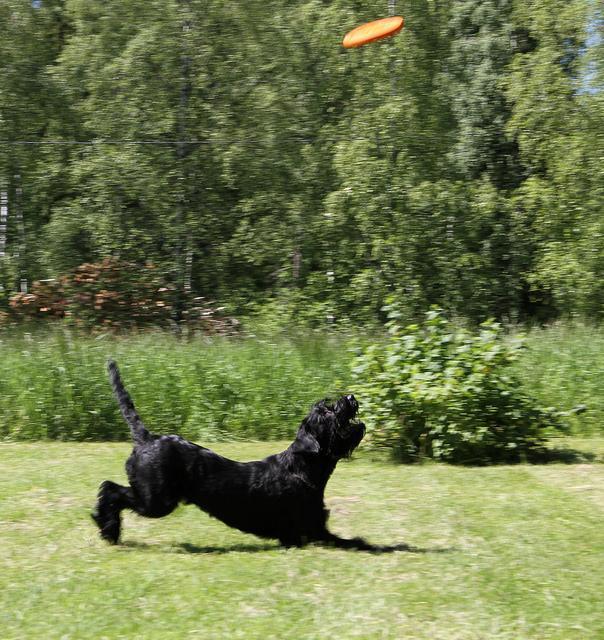How many people are watching the tennis player?
Give a very brief answer. 0. 